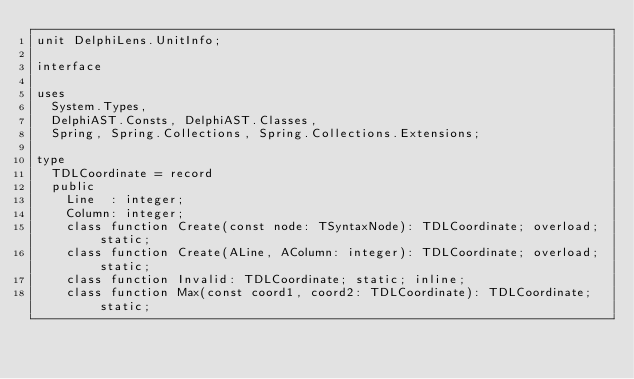Convert code to text. <code><loc_0><loc_0><loc_500><loc_500><_Pascal_>unit DelphiLens.UnitInfo;

interface

uses
  System.Types,
  DelphiAST.Consts, DelphiAST.Classes,
  Spring, Spring.Collections, Spring.Collections.Extensions;

type
  TDLCoordinate = record
  public
    Line  : integer;
    Column: integer;
    class function Create(const node: TSyntaxNode): TDLCoordinate; overload; static;
    class function Create(ALine, AColumn: integer): TDLCoordinate; overload; static;
    class function Invalid: TDLCoordinate; static; inline;
    class function Max(const coord1, coord2: TDLCoordinate): TDLCoordinate; static;</code> 